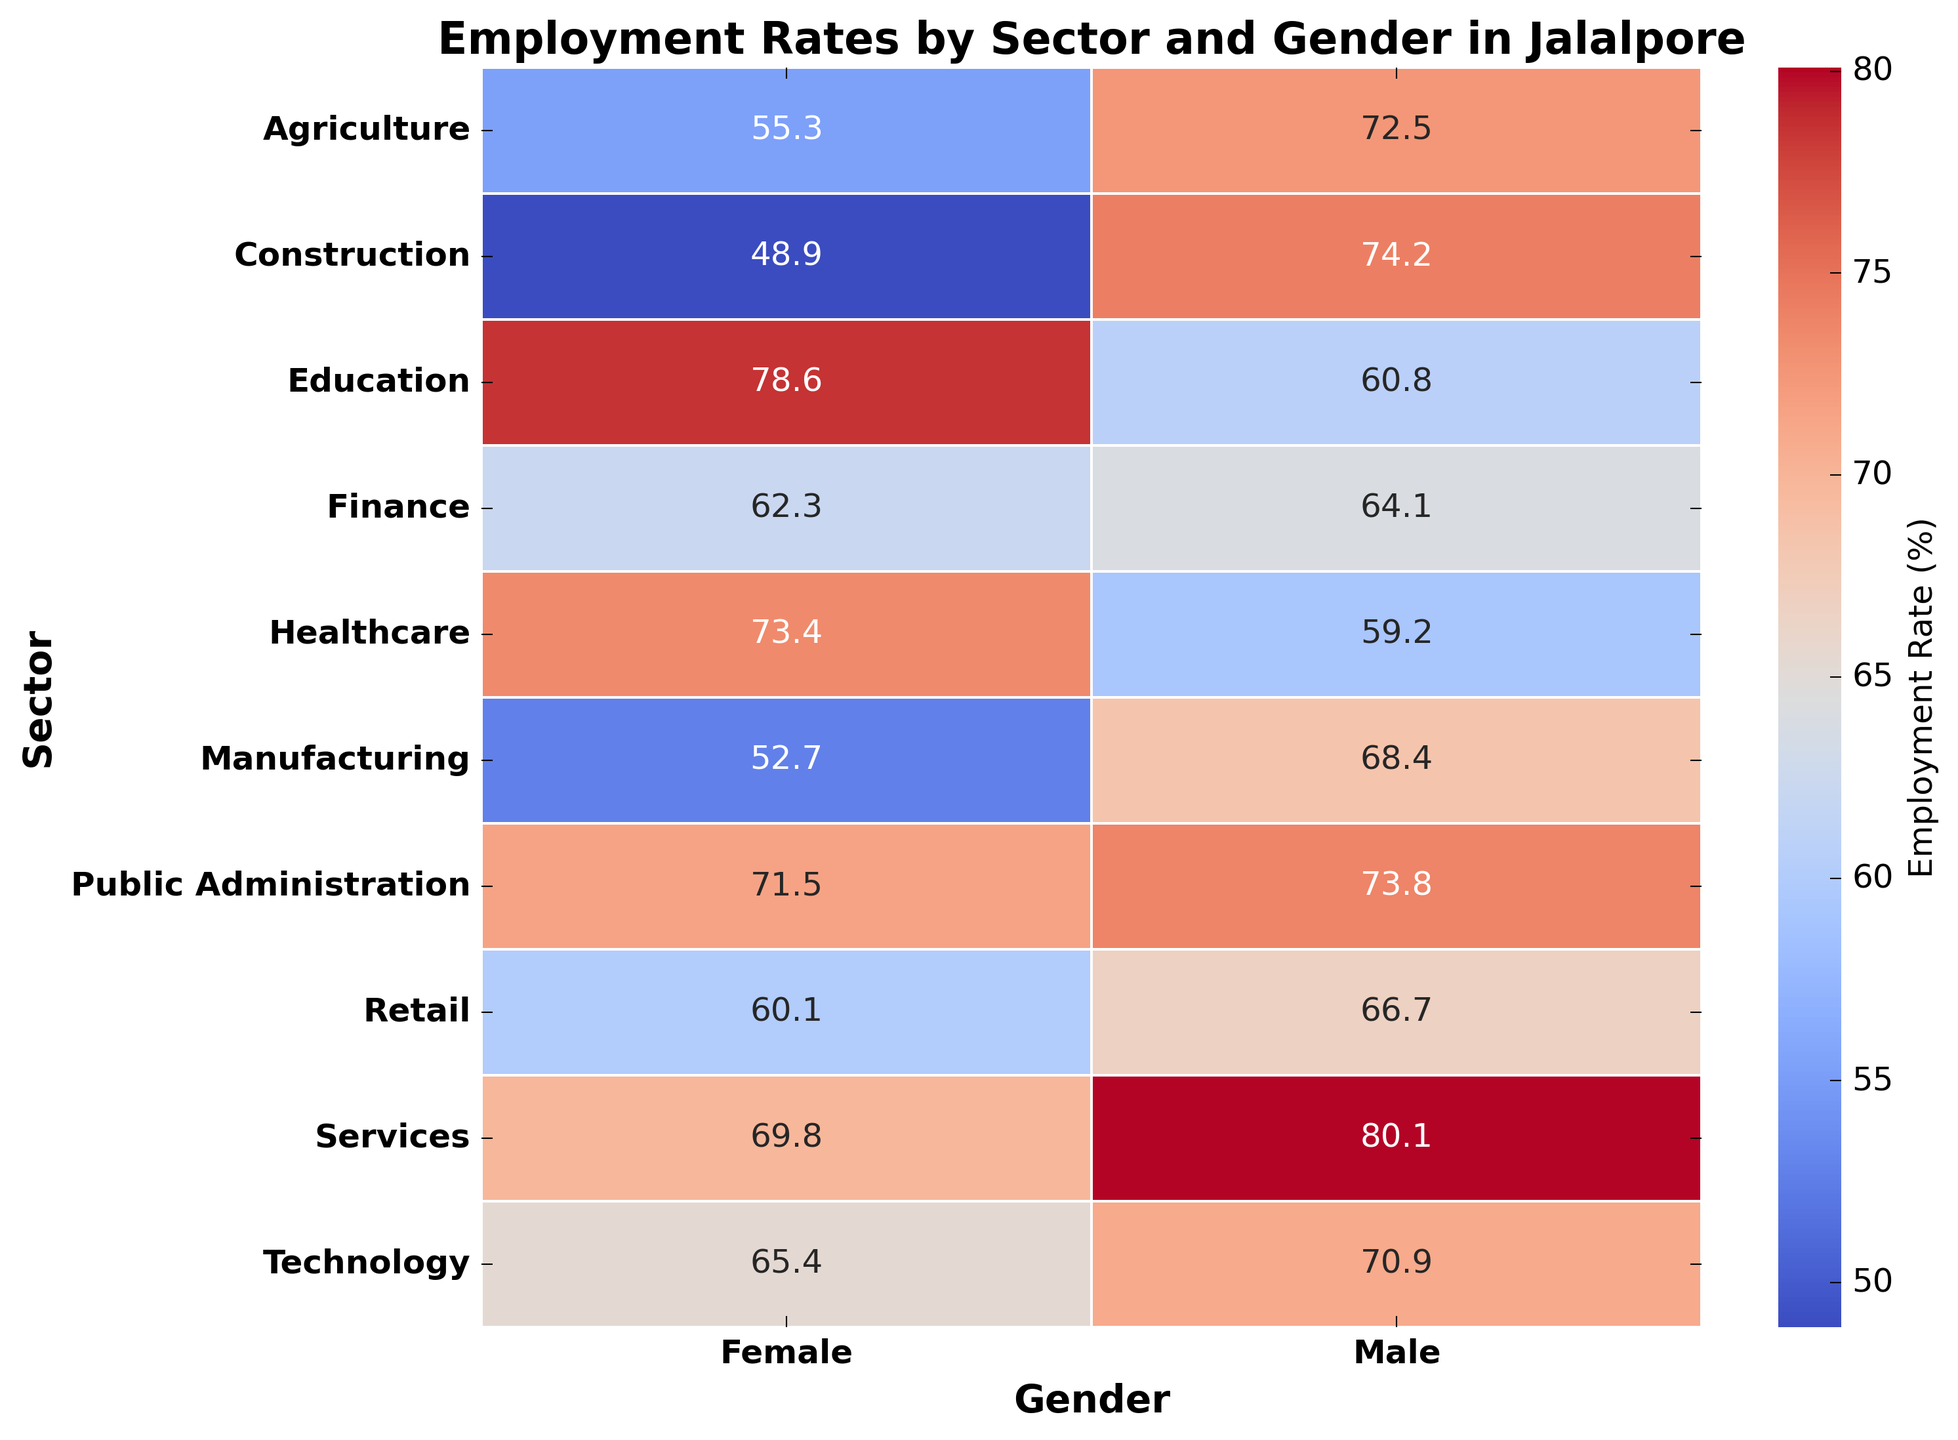Which sector has the highest employment rate for males? The sectors listed for males have different employment rates, and Services have the highest value of 80.1
Answer: Services Which sector shows the biggest difference in employment rates between males and females? Calculating the difference for each sector: Agriculture (17.2), Manufacturing (15.7), Services (10.3), Construction (25.3), Retail (6.6), Healthcare (14.2), Education (17.8), Technology (5.5), Finance (1.8), Public Administration (2.3); Construction has the largest difference of 25.3
Answer: Construction What is the average employment rate for females across all sectors? Summing the employment rates for females: (55.3 + 52.7 + 69.8 + 48.9 + 60.1 + 73.4 + 78.6 + 65.4 + 62.3 + 71.5) = 637.1; then dividing by the total number of sectors (10): 637.1 / 10 = 63.71
Answer: 63.7 In which sector is the employment rate for females greater than for males? Comparing employment rates: Healthcare (Females 73.4 > Males 59.2), Education (Females 78.6 > Males 60.8)
Answer: Healthcare, Education Which gender has higher employment rates overall in Jalalpore based on the heatmap? Summing employment rates for males (72.5 + 68.4 + 80.1 + 74.2 + 66.7 + 59.2 + 60.8 + 70.9 + 64.1 + 73.8) = 690.7; for females (55.3 + 52.7 + 69.8 + 48.9 + 60.1 + 73.4 + 78.6 + 65.4 + 62.3 + 71.5) = 637.1; Males have higher overall rates.
Answer: Males What is the most noticeable visual pattern in the heatmap for employment rates across sectors and gender? The employment rates for males are generally higher than those for females in most sectors, except in Healthcare and Education where females have higher employment rates. This creates a pattern of lower employment rates for females except in these two sectors.
Answer: Males generally higher except Healthcare and Education 